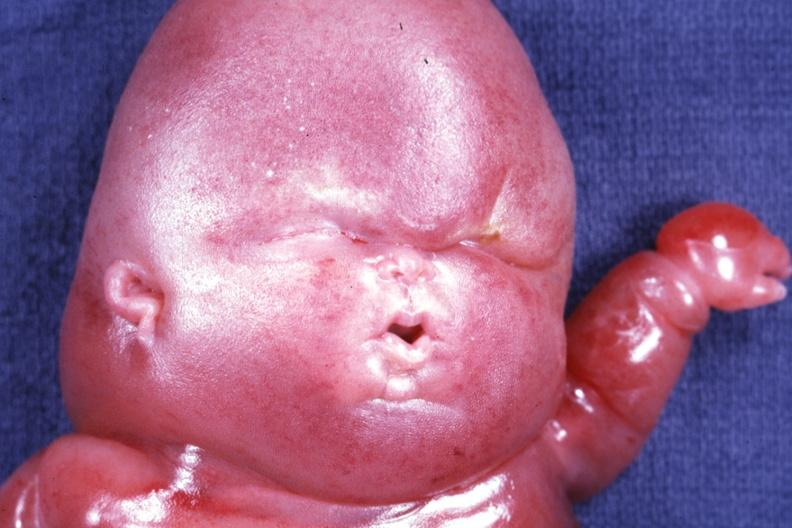what is present?
Answer the question using a single word or phrase. Lymphangiomatosis 